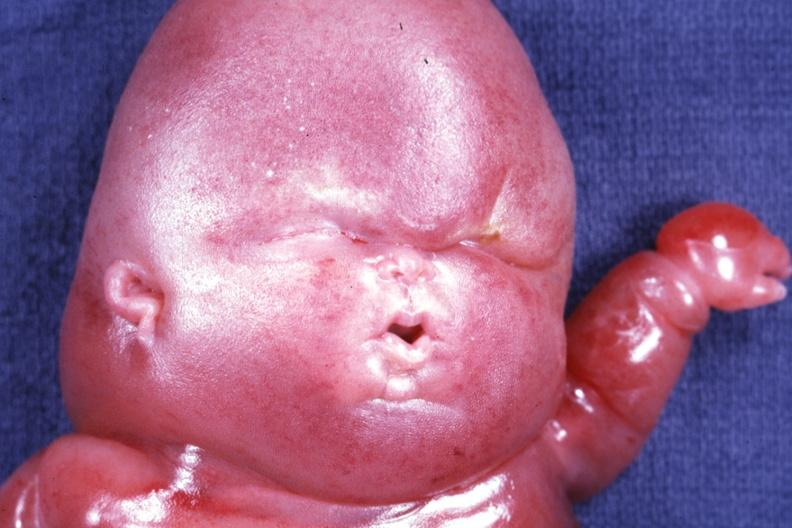what is present?
Answer the question using a single word or phrase. Lymphangiomatosis 